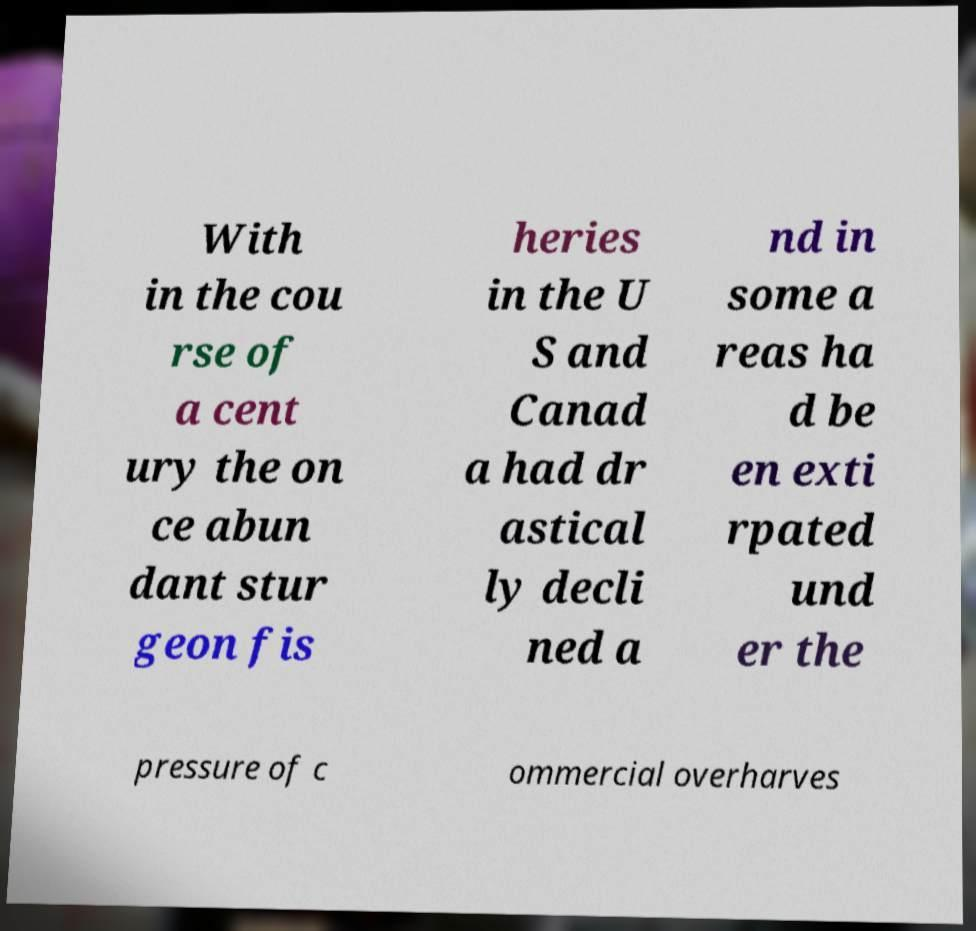I need the written content from this picture converted into text. Can you do that? With in the cou rse of a cent ury the on ce abun dant stur geon fis heries in the U S and Canad a had dr astical ly decli ned a nd in some a reas ha d be en exti rpated und er the pressure of c ommercial overharves 